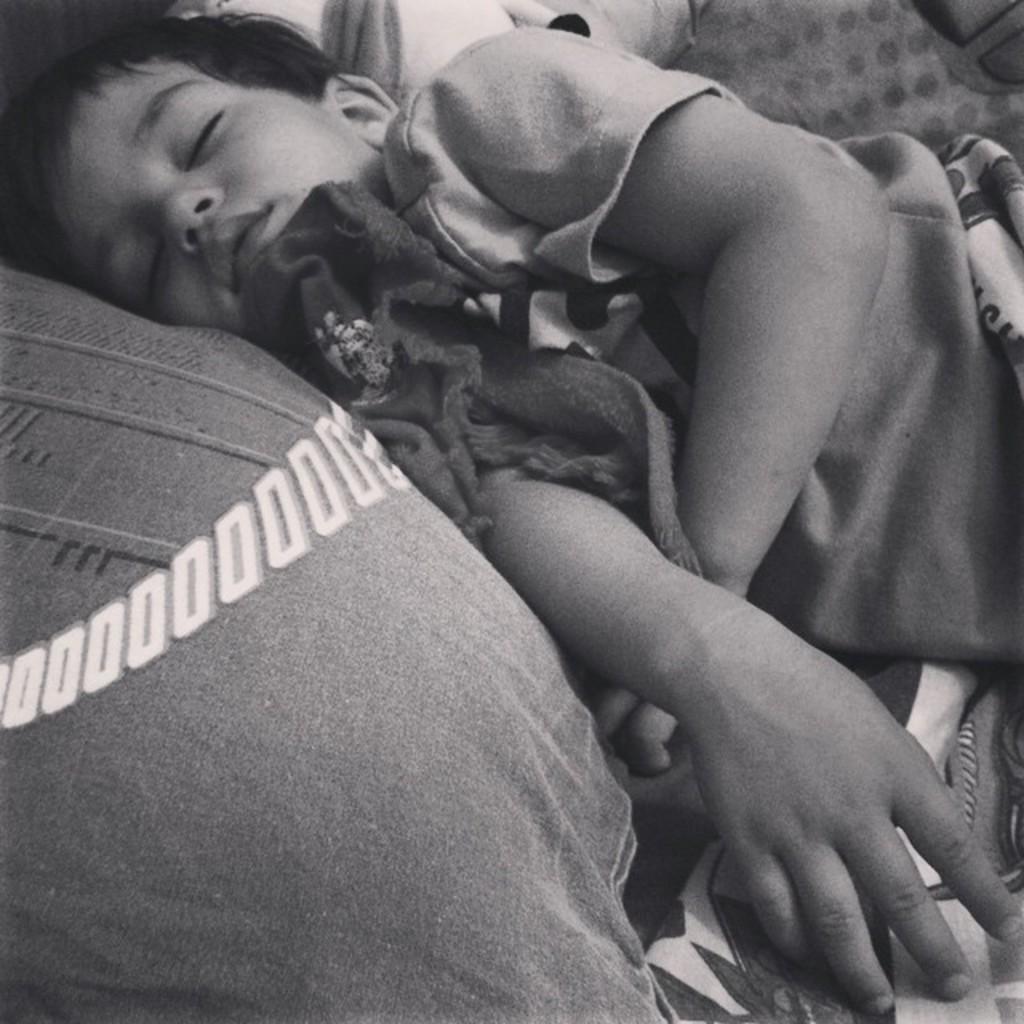In one or two sentences, can you explain what this image depicts? In this image there is a boy sleeping on the bed. Beside him there is a pillow. 